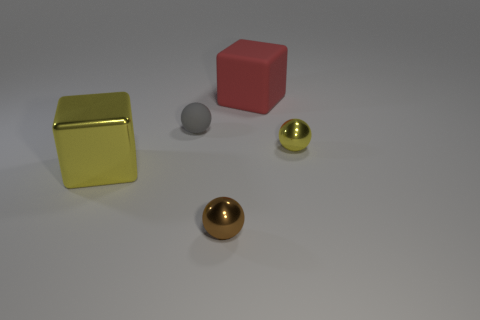Add 2 small red matte spheres. How many objects exist? 7 Subtract all cubes. How many objects are left? 3 Subtract all big brown things. Subtract all large metallic cubes. How many objects are left? 4 Add 5 large yellow shiny things. How many large yellow shiny things are left? 6 Add 2 gray balls. How many gray balls exist? 3 Subtract 1 red blocks. How many objects are left? 4 